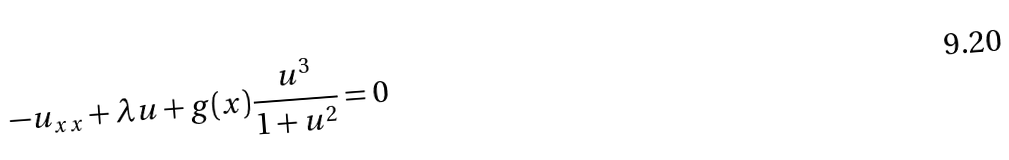<formula> <loc_0><loc_0><loc_500><loc_500>- u _ { x x } + \lambda u + g ( x ) \frac { u ^ { 3 } } { 1 + u ^ { 2 } } = 0</formula> 